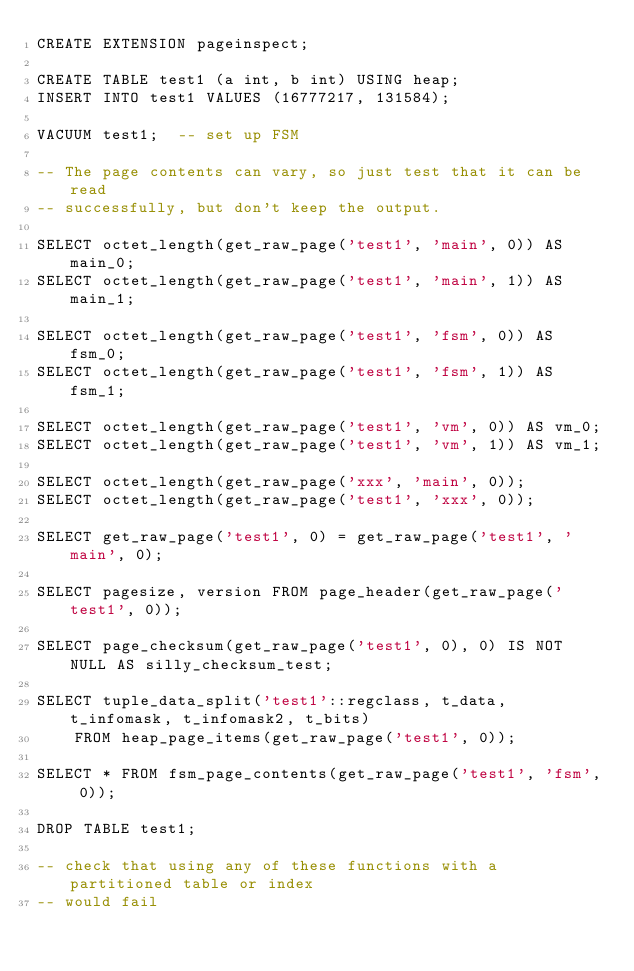Convert code to text. <code><loc_0><loc_0><loc_500><loc_500><_SQL_>CREATE EXTENSION pageinspect;

CREATE TABLE test1 (a int, b int) USING heap;
INSERT INTO test1 VALUES (16777217, 131584);

VACUUM test1;  -- set up FSM

-- The page contents can vary, so just test that it can be read
-- successfully, but don't keep the output.

SELECT octet_length(get_raw_page('test1', 'main', 0)) AS main_0;
SELECT octet_length(get_raw_page('test1', 'main', 1)) AS main_1;

SELECT octet_length(get_raw_page('test1', 'fsm', 0)) AS fsm_0;
SELECT octet_length(get_raw_page('test1', 'fsm', 1)) AS fsm_1;

SELECT octet_length(get_raw_page('test1', 'vm', 0)) AS vm_0;
SELECT octet_length(get_raw_page('test1', 'vm', 1)) AS vm_1;

SELECT octet_length(get_raw_page('xxx', 'main', 0));
SELECT octet_length(get_raw_page('test1', 'xxx', 0));

SELECT get_raw_page('test1', 0) = get_raw_page('test1', 'main', 0);

SELECT pagesize, version FROM page_header(get_raw_page('test1', 0));

SELECT page_checksum(get_raw_page('test1', 0), 0) IS NOT NULL AS silly_checksum_test;

SELECT tuple_data_split('test1'::regclass, t_data, t_infomask, t_infomask2, t_bits)
    FROM heap_page_items(get_raw_page('test1', 0));

SELECT * FROM fsm_page_contents(get_raw_page('test1', 'fsm', 0));

DROP TABLE test1;

-- check that using any of these functions with a partitioned table or index
-- would fail</code> 